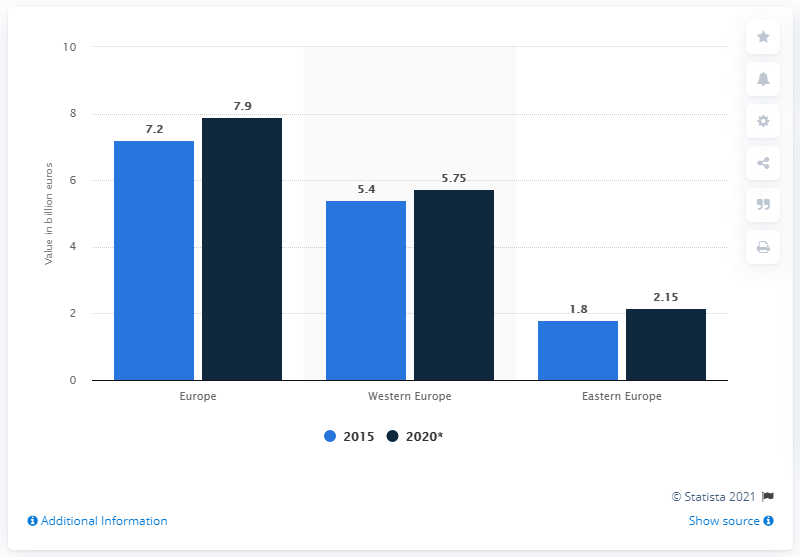List a handful of essential elements in this visual. In 2015, the maximum value of dietary supplements was 5.05, while in 2020, the minimum value of dietary supplements was 5.05. The value of the dietary supplement market in Western Europe in 2015 was 5.4 billion dollars. The value of dietary supplements in Europe in 2015 was approximately 7.2 billion euros. 